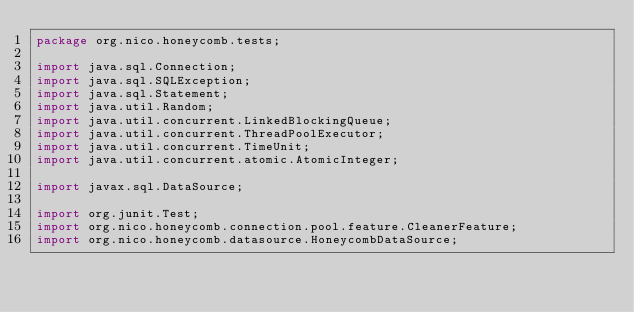Convert code to text. <code><loc_0><loc_0><loc_500><loc_500><_Java_>package org.nico.honeycomb.tests;

import java.sql.Connection;
import java.sql.SQLException;
import java.sql.Statement;
import java.util.Random;
import java.util.concurrent.LinkedBlockingQueue;
import java.util.concurrent.ThreadPoolExecutor;
import java.util.concurrent.TimeUnit;
import java.util.concurrent.atomic.AtomicInteger;

import javax.sql.DataSource;

import org.junit.Test;
import org.nico.honeycomb.connection.pool.feature.CleanerFeature;
import org.nico.honeycomb.datasource.HoneycombDataSource;
</code> 